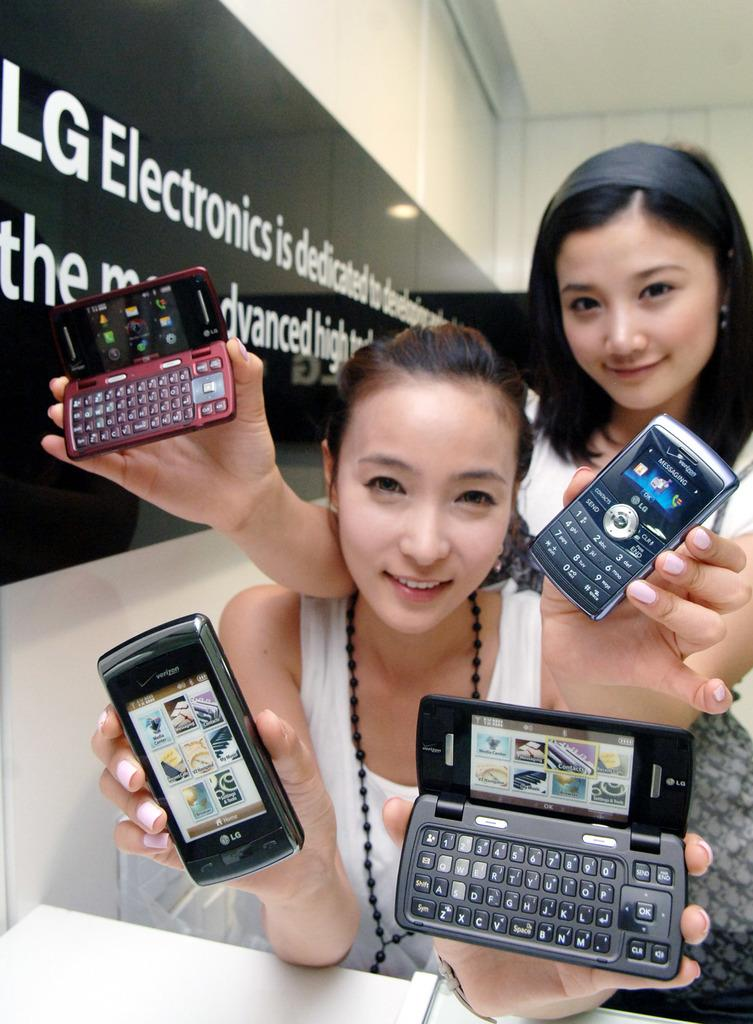<image>
Present a compact description of the photo's key features. Two girls are holding cell phones in front of a sign that says LG Electronics. 